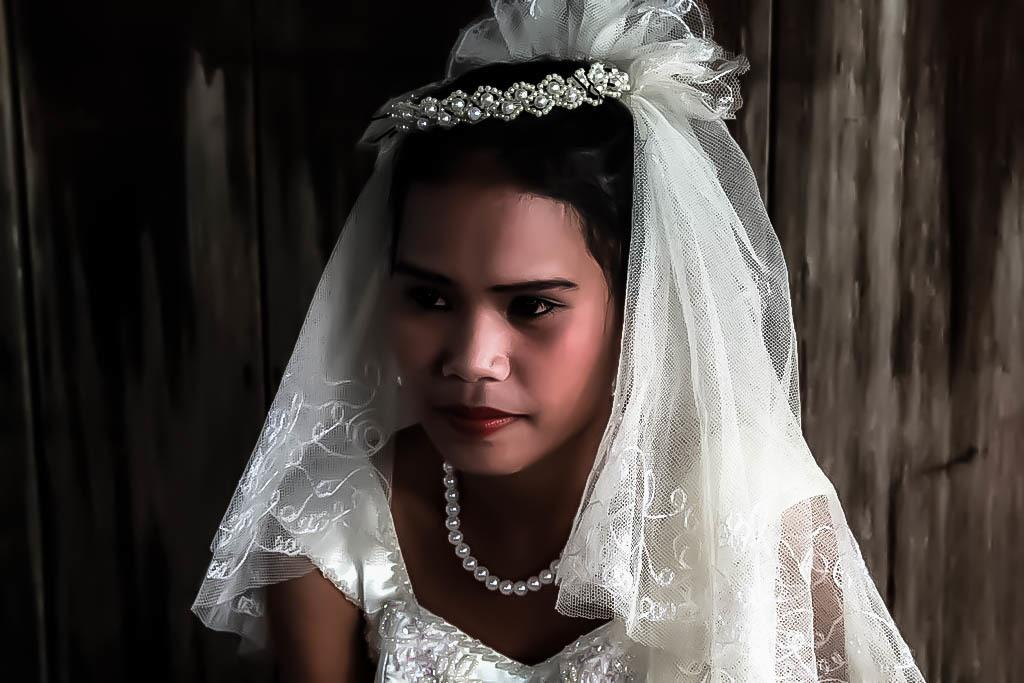What is present in the image? There is a person in the image. Can you describe the person's attire? The person is wearing a white dress. What accessory is the person wearing in the image? The person has a pearl set on her neck. What type of popcorn is the person eating in the image? There is no popcorn present in the image. What is the person's income based on the image? The image does not provide any information about the person's income. 